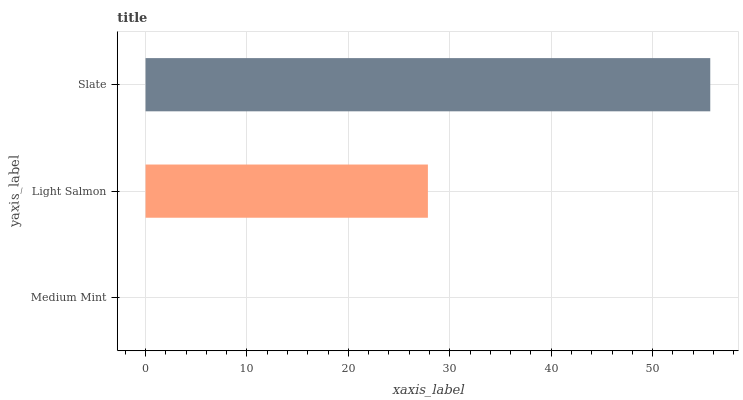Is Medium Mint the minimum?
Answer yes or no. Yes. Is Slate the maximum?
Answer yes or no. Yes. Is Light Salmon the minimum?
Answer yes or no. No. Is Light Salmon the maximum?
Answer yes or no. No. Is Light Salmon greater than Medium Mint?
Answer yes or no. Yes. Is Medium Mint less than Light Salmon?
Answer yes or no. Yes. Is Medium Mint greater than Light Salmon?
Answer yes or no. No. Is Light Salmon less than Medium Mint?
Answer yes or no. No. Is Light Salmon the high median?
Answer yes or no. Yes. Is Light Salmon the low median?
Answer yes or no. Yes. Is Slate the high median?
Answer yes or no. No. Is Slate the low median?
Answer yes or no. No. 